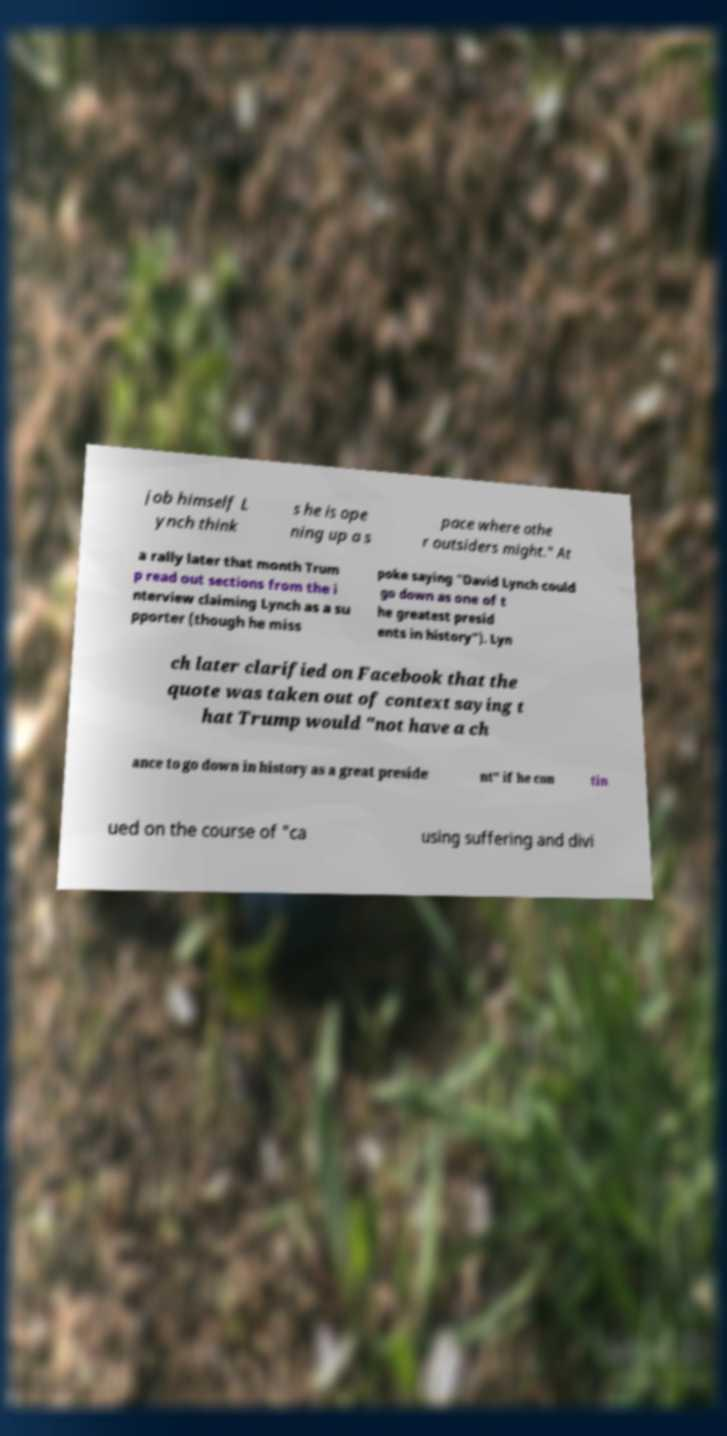For documentation purposes, I need the text within this image transcribed. Could you provide that? job himself L ynch think s he is ope ning up a s pace where othe r outsiders might." At a rally later that month Trum p read out sections from the i nterview claiming Lynch as a su pporter (though he miss poke saying "David Lynch could go down as one of t he greatest presid ents in history"). Lyn ch later clarified on Facebook that the quote was taken out of context saying t hat Trump would "not have a ch ance to go down in history as a great preside nt" if he con tin ued on the course of "ca using suffering and divi 